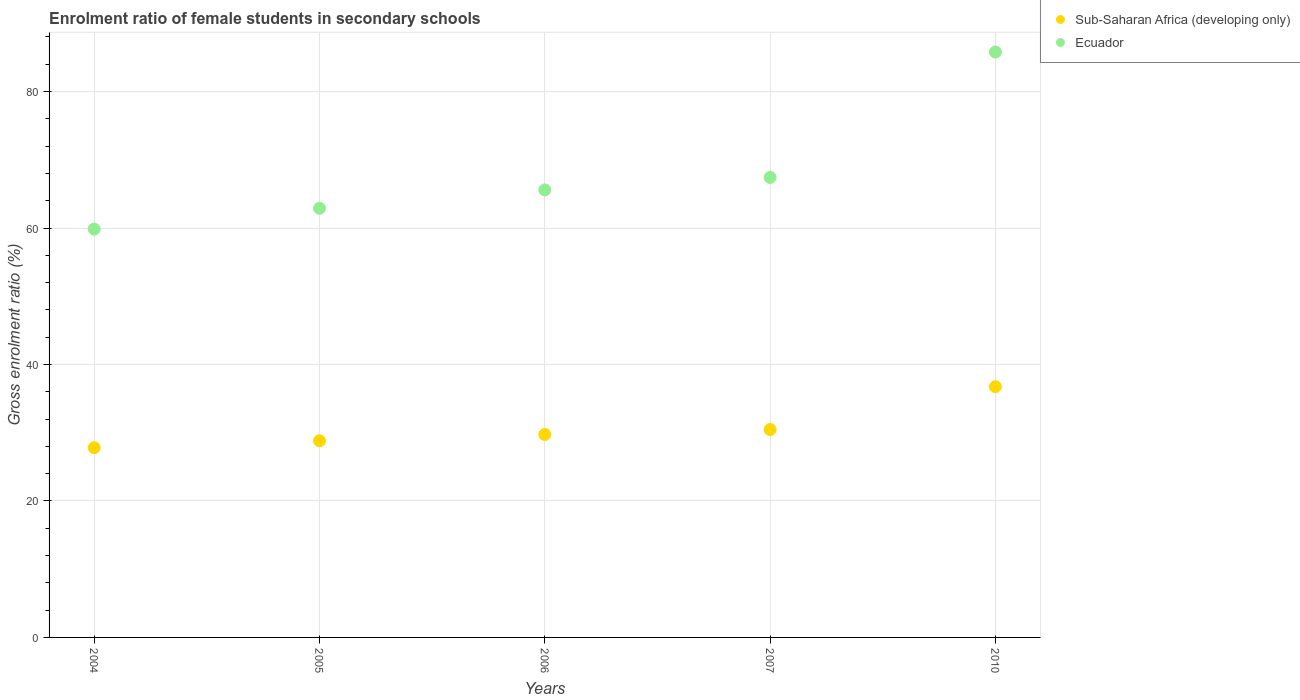What is the enrolment ratio of female students in secondary schools in Sub-Saharan Africa (developing only) in 2005?
Offer a terse response. 28.82. Across all years, what is the maximum enrolment ratio of female students in secondary schools in Ecuador?
Keep it short and to the point. 85.79. Across all years, what is the minimum enrolment ratio of female students in secondary schools in Ecuador?
Ensure brevity in your answer.  59.84. In which year was the enrolment ratio of female students in secondary schools in Ecuador maximum?
Provide a short and direct response. 2010. In which year was the enrolment ratio of female students in secondary schools in Ecuador minimum?
Offer a very short reply. 2004. What is the total enrolment ratio of female students in secondary schools in Ecuador in the graph?
Give a very brief answer. 341.52. What is the difference between the enrolment ratio of female students in secondary schools in Ecuador in 2007 and that in 2010?
Provide a succinct answer. -18.37. What is the difference between the enrolment ratio of female students in secondary schools in Sub-Saharan Africa (developing only) in 2005 and the enrolment ratio of female students in secondary schools in Ecuador in 2010?
Give a very brief answer. -56.96. What is the average enrolment ratio of female students in secondary schools in Sub-Saharan Africa (developing only) per year?
Give a very brief answer. 30.72. In the year 2005, what is the difference between the enrolment ratio of female students in secondary schools in Ecuador and enrolment ratio of female students in secondary schools in Sub-Saharan Africa (developing only)?
Provide a short and direct response. 34.07. In how many years, is the enrolment ratio of female students in secondary schools in Ecuador greater than 28 %?
Your response must be concise. 5. What is the ratio of the enrolment ratio of female students in secondary schools in Sub-Saharan Africa (developing only) in 2006 to that in 2007?
Offer a very short reply. 0.98. Is the enrolment ratio of female students in secondary schools in Ecuador in 2004 less than that in 2007?
Offer a very short reply. Yes. What is the difference between the highest and the second highest enrolment ratio of female students in secondary schools in Sub-Saharan Africa (developing only)?
Ensure brevity in your answer.  6.28. What is the difference between the highest and the lowest enrolment ratio of female students in secondary schools in Sub-Saharan Africa (developing only)?
Make the answer very short. 8.94. In how many years, is the enrolment ratio of female students in secondary schools in Ecuador greater than the average enrolment ratio of female students in secondary schools in Ecuador taken over all years?
Offer a terse response. 1. Is the sum of the enrolment ratio of female students in secondary schools in Ecuador in 2004 and 2007 greater than the maximum enrolment ratio of female students in secondary schools in Sub-Saharan Africa (developing only) across all years?
Make the answer very short. Yes. Does the enrolment ratio of female students in secondary schools in Ecuador monotonically increase over the years?
Provide a succinct answer. Yes. Is the enrolment ratio of female students in secondary schools in Ecuador strictly less than the enrolment ratio of female students in secondary schools in Sub-Saharan Africa (developing only) over the years?
Give a very brief answer. No. How many dotlines are there?
Give a very brief answer. 2. What is the difference between two consecutive major ticks on the Y-axis?
Ensure brevity in your answer.  20. Does the graph contain any zero values?
Offer a very short reply. No. Does the graph contain grids?
Your answer should be compact. Yes. How many legend labels are there?
Offer a very short reply. 2. What is the title of the graph?
Provide a succinct answer. Enrolment ratio of female students in secondary schools. What is the Gross enrolment ratio (%) in Sub-Saharan Africa (developing only) in 2004?
Your answer should be very brief. 27.8. What is the Gross enrolment ratio (%) in Ecuador in 2004?
Offer a terse response. 59.84. What is the Gross enrolment ratio (%) in Sub-Saharan Africa (developing only) in 2005?
Provide a succinct answer. 28.82. What is the Gross enrolment ratio (%) of Ecuador in 2005?
Give a very brief answer. 62.89. What is the Gross enrolment ratio (%) of Sub-Saharan Africa (developing only) in 2006?
Give a very brief answer. 29.75. What is the Gross enrolment ratio (%) in Ecuador in 2006?
Your answer should be very brief. 65.58. What is the Gross enrolment ratio (%) of Sub-Saharan Africa (developing only) in 2007?
Make the answer very short. 30.46. What is the Gross enrolment ratio (%) of Ecuador in 2007?
Your answer should be very brief. 67.42. What is the Gross enrolment ratio (%) in Sub-Saharan Africa (developing only) in 2010?
Ensure brevity in your answer.  36.75. What is the Gross enrolment ratio (%) of Ecuador in 2010?
Provide a short and direct response. 85.79. Across all years, what is the maximum Gross enrolment ratio (%) of Sub-Saharan Africa (developing only)?
Your answer should be very brief. 36.75. Across all years, what is the maximum Gross enrolment ratio (%) of Ecuador?
Your answer should be very brief. 85.79. Across all years, what is the minimum Gross enrolment ratio (%) of Sub-Saharan Africa (developing only)?
Make the answer very short. 27.8. Across all years, what is the minimum Gross enrolment ratio (%) of Ecuador?
Provide a short and direct response. 59.84. What is the total Gross enrolment ratio (%) of Sub-Saharan Africa (developing only) in the graph?
Give a very brief answer. 153.58. What is the total Gross enrolment ratio (%) in Ecuador in the graph?
Keep it short and to the point. 341.52. What is the difference between the Gross enrolment ratio (%) in Sub-Saharan Africa (developing only) in 2004 and that in 2005?
Provide a succinct answer. -1.02. What is the difference between the Gross enrolment ratio (%) of Ecuador in 2004 and that in 2005?
Your answer should be compact. -3.05. What is the difference between the Gross enrolment ratio (%) of Sub-Saharan Africa (developing only) in 2004 and that in 2006?
Your answer should be very brief. -1.94. What is the difference between the Gross enrolment ratio (%) of Ecuador in 2004 and that in 2006?
Your answer should be compact. -5.74. What is the difference between the Gross enrolment ratio (%) in Sub-Saharan Africa (developing only) in 2004 and that in 2007?
Offer a terse response. -2.66. What is the difference between the Gross enrolment ratio (%) in Ecuador in 2004 and that in 2007?
Your answer should be very brief. -7.57. What is the difference between the Gross enrolment ratio (%) of Sub-Saharan Africa (developing only) in 2004 and that in 2010?
Make the answer very short. -8.94. What is the difference between the Gross enrolment ratio (%) of Ecuador in 2004 and that in 2010?
Ensure brevity in your answer.  -25.95. What is the difference between the Gross enrolment ratio (%) in Sub-Saharan Africa (developing only) in 2005 and that in 2006?
Make the answer very short. -0.92. What is the difference between the Gross enrolment ratio (%) in Ecuador in 2005 and that in 2006?
Offer a very short reply. -2.69. What is the difference between the Gross enrolment ratio (%) of Sub-Saharan Africa (developing only) in 2005 and that in 2007?
Ensure brevity in your answer.  -1.64. What is the difference between the Gross enrolment ratio (%) in Ecuador in 2005 and that in 2007?
Provide a succinct answer. -4.53. What is the difference between the Gross enrolment ratio (%) in Sub-Saharan Africa (developing only) in 2005 and that in 2010?
Give a very brief answer. -7.92. What is the difference between the Gross enrolment ratio (%) of Ecuador in 2005 and that in 2010?
Give a very brief answer. -22.9. What is the difference between the Gross enrolment ratio (%) in Sub-Saharan Africa (developing only) in 2006 and that in 2007?
Keep it short and to the point. -0.72. What is the difference between the Gross enrolment ratio (%) of Ecuador in 2006 and that in 2007?
Give a very brief answer. -1.83. What is the difference between the Gross enrolment ratio (%) of Sub-Saharan Africa (developing only) in 2006 and that in 2010?
Your answer should be compact. -7. What is the difference between the Gross enrolment ratio (%) of Ecuador in 2006 and that in 2010?
Provide a short and direct response. -20.21. What is the difference between the Gross enrolment ratio (%) of Sub-Saharan Africa (developing only) in 2007 and that in 2010?
Keep it short and to the point. -6.28. What is the difference between the Gross enrolment ratio (%) of Ecuador in 2007 and that in 2010?
Offer a terse response. -18.37. What is the difference between the Gross enrolment ratio (%) in Sub-Saharan Africa (developing only) in 2004 and the Gross enrolment ratio (%) in Ecuador in 2005?
Keep it short and to the point. -35.09. What is the difference between the Gross enrolment ratio (%) of Sub-Saharan Africa (developing only) in 2004 and the Gross enrolment ratio (%) of Ecuador in 2006?
Make the answer very short. -37.78. What is the difference between the Gross enrolment ratio (%) of Sub-Saharan Africa (developing only) in 2004 and the Gross enrolment ratio (%) of Ecuador in 2007?
Offer a very short reply. -39.61. What is the difference between the Gross enrolment ratio (%) in Sub-Saharan Africa (developing only) in 2004 and the Gross enrolment ratio (%) in Ecuador in 2010?
Your answer should be compact. -57.98. What is the difference between the Gross enrolment ratio (%) of Sub-Saharan Africa (developing only) in 2005 and the Gross enrolment ratio (%) of Ecuador in 2006?
Keep it short and to the point. -36.76. What is the difference between the Gross enrolment ratio (%) of Sub-Saharan Africa (developing only) in 2005 and the Gross enrolment ratio (%) of Ecuador in 2007?
Your answer should be very brief. -38.59. What is the difference between the Gross enrolment ratio (%) of Sub-Saharan Africa (developing only) in 2005 and the Gross enrolment ratio (%) of Ecuador in 2010?
Keep it short and to the point. -56.96. What is the difference between the Gross enrolment ratio (%) in Sub-Saharan Africa (developing only) in 2006 and the Gross enrolment ratio (%) in Ecuador in 2007?
Keep it short and to the point. -37.67. What is the difference between the Gross enrolment ratio (%) in Sub-Saharan Africa (developing only) in 2006 and the Gross enrolment ratio (%) in Ecuador in 2010?
Provide a short and direct response. -56.04. What is the difference between the Gross enrolment ratio (%) in Sub-Saharan Africa (developing only) in 2007 and the Gross enrolment ratio (%) in Ecuador in 2010?
Your answer should be compact. -55.32. What is the average Gross enrolment ratio (%) in Sub-Saharan Africa (developing only) per year?
Provide a short and direct response. 30.72. What is the average Gross enrolment ratio (%) in Ecuador per year?
Keep it short and to the point. 68.3. In the year 2004, what is the difference between the Gross enrolment ratio (%) of Sub-Saharan Africa (developing only) and Gross enrolment ratio (%) of Ecuador?
Offer a very short reply. -32.04. In the year 2005, what is the difference between the Gross enrolment ratio (%) in Sub-Saharan Africa (developing only) and Gross enrolment ratio (%) in Ecuador?
Ensure brevity in your answer.  -34.07. In the year 2006, what is the difference between the Gross enrolment ratio (%) in Sub-Saharan Africa (developing only) and Gross enrolment ratio (%) in Ecuador?
Your answer should be very brief. -35.84. In the year 2007, what is the difference between the Gross enrolment ratio (%) in Sub-Saharan Africa (developing only) and Gross enrolment ratio (%) in Ecuador?
Make the answer very short. -36.95. In the year 2010, what is the difference between the Gross enrolment ratio (%) in Sub-Saharan Africa (developing only) and Gross enrolment ratio (%) in Ecuador?
Give a very brief answer. -49.04. What is the ratio of the Gross enrolment ratio (%) in Sub-Saharan Africa (developing only) in 2004 to that in 2005?
Make the answer very short. 0.96. What is the ratio of the Gross enrolment ratio (%) in Ecuador in 2004 to that in 2005?
Provide a short and direct response. 0.95. What is the ratio of the Gross enrolment ratio (%) of Sub-Saharan Africa (developing only) in 2004 to that in 2006?
Keep it short and to the point. 0.93. What is the ratio of the Gross enrolment ratio (%) of Ecuador in 2004 to that in 2006?
Your answer should be very brief. 0.91. What is the ratio of the Gross enrolment ratio (%) of Sub-Saharan Africa (developing only) in 2004 to that in 2007?
Offer a terse response. 0.91. What is the ratio of the Gross enrolment ratio (%) of Ecuador in 2004 to that in 2007?
Your response must be concise. 0.89. What is the ratio of the Gross enrolment ratio (%) in Sub-Saharan Africa (developing only) in 2004 to that in 2010?
Provide a short and direct response. 0.76. What is the ratio of the Gross enrolment ratio (%) in Ecuador in 2004 to that in 2010?
Give a very brief answer. 0.7. What is the ratio of the Gross enrolment ratio (%) in Sub-Saharan Africa (developing only) in 2005 to that in 2006?
Offer a terse response. 0.97. What is the ratio of the Gross enrolment ratio (%) in Ecuador in 2005 to that in 2006?
Make the answer very short. 0.96. What is the ratio of the Gross enrolment ratio (%) in Sub-Saharan Africa (developing only) in 2005 to that in 2007?
Offer a very short reply. 0.95. What is the ratio of the Gross enrolment ratio (%) of Ecuador in 2005 to that in 2007?
Ensure brevity in your answer.  0.93. What is the ratio of the Gross enrolment ratio (%) in Sub-Saharan Africa (developing only) in 2005 to that in 2010?
Provide a short and direct response. 0.78. What is the ratio of the Gross enrolment ratio (%) in Ecuador in 2005 to that in 2010?
Your response must be concise. 0.73. What is the ratio of the Gross enrolment ratio (%) of Sub-Saharan Africa (developing only) in 2006 to that in 2007?
Offer a very short reply. 0.98. What is the ratio of the Gross enrolment ratio (%) in Ecuador in 2006 to that in 2007?
Offer a very short reply. 0.97. What is the ratio of the Gross enrolment ratio (%) of Sub-Saharan Africa (developing only) in 2006 to that in 2010?
Give a very brief answer. 0.81. What is the ratio of the Gross enrolment ratio (%) in Ecuador in 2006 to that in 2010?
Your response must be concise. 0.76. What is the ratio of the Gross enrolment ratio (%) in Sub-Saharan Africa (developing only) in 2007 to that in 2010?
Ensure brevity in your answer.  0.83. What is the ratio of the Gross enrolment ratio (%) of Ecuador in 2007 to that in 2010?
Offer a terse response. 0.79. What is the difference between the highest and the second highest Gross enrolment ratio (%) of Sub-Saharan Africa (developing only)?
Offer a terse response. 6.28. What is the difference between the highest and the second highest Gross enrolment ratio (%) in Ecuador?
Make the answer very short. 18.37. What is the difference between the highest and the lowest Gross enrolment ratio (%) of Sub-Saharan Africa (developing only)?
Your answer should be very brief. 8.94. What is the difference between the highest and the lowest Gross enrolment ratio (%) in Ecuador?
Ensure brevity in your answer.  25.95. 